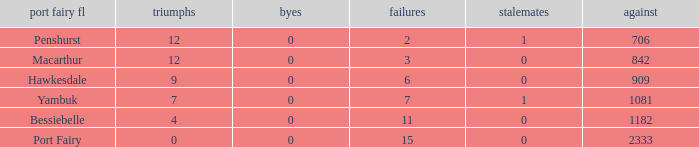How many byes when the draws are less than 0? 0.0. 